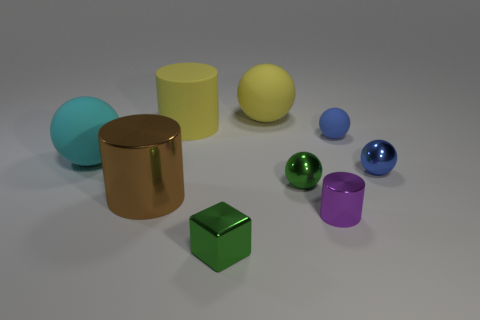Can you tell me which objects are closest to the purple cylinder? Adjacent to the purple cylinder, there is a blue sphere on one side and a green sphere and metal cylinder on the other side that are closer compared to other items. 